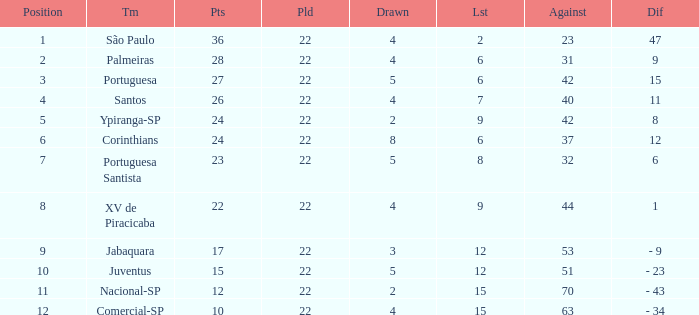Which Against has a Drawn smaller than 5, and a Lost smaller than 6, and a Points larger than 36? 0.0. 